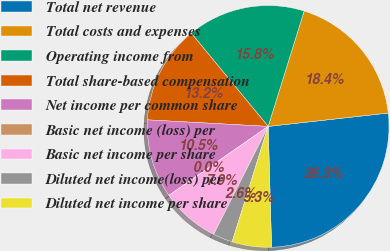<chart> <loc_0><loc_0><loc_500><loc_500><pie_chart><fcel>Total net revenue<fcel>Total costs and expenses<fcel>Operating income from<fcel>Total share-based compensation<fcel>Net income per common share<fcel>Basic net income (loss) per<fcel>Basic net income per share<fcel>Diluted net income(loss) per<fcel>Diluted net income per share<nl><fcel>26.32%<fcel>18.42%<fcel>15.79%<fcel>13.16%<fcel>10.53%<fcel>0.0%<fcel>7.89%<fcel>2.63%<fcel>5.26%<nl></chart> 